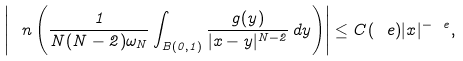Convert formula to latex. <formula><loc_0><loc_0><loc_500><loc_500>\left | \ n \left ( \frac { 1 } { N ( N - 2 ) \omega _ { N } } \int _ { B ( 0 , 1 ) } \frac { g ( y ) } { | x - y | ^ { N - 2 } } \, d y \right ) \right | \leq C ( \ e ) | x | ^ { - \ e } ,</formula> 